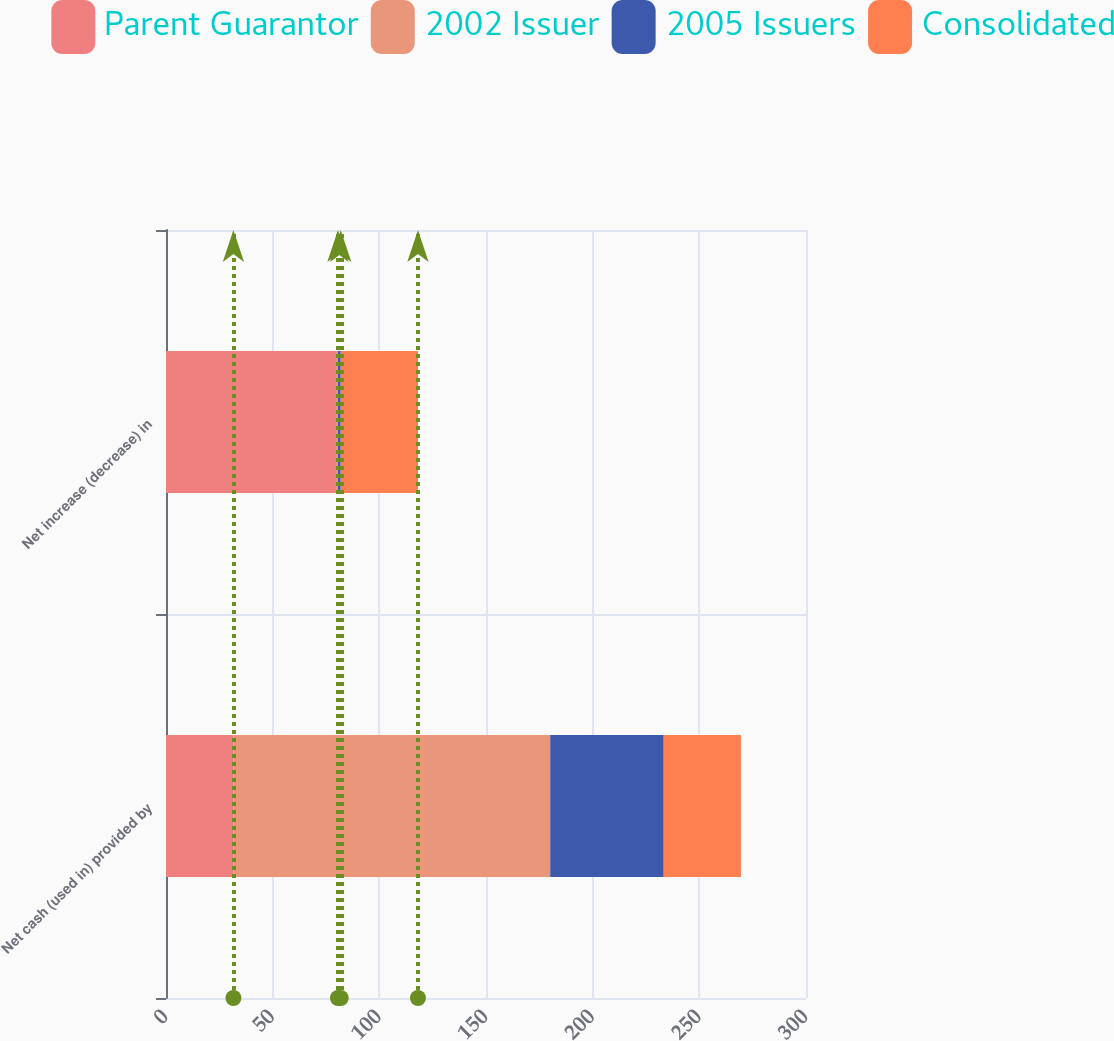Convert chart. <chart><loc_0><loc_0><loc_500><loc_500><stacked_bar_chart><ecel><fcel>Net cash (used in) provided by<fcel>Net increase (decrease) in<nl><fcel>Parent Guarantor<fcel>31.6<fcel>80.1<nl><fcel>2002 Issuer<fcel>148.5<fcel>0.5<nl><fcel>2005 Issuers<fcel>53.2<fcel>1.3<nl><fcel>Consolidated<fcel>36.2<fcel>36.2<nl></chart> 